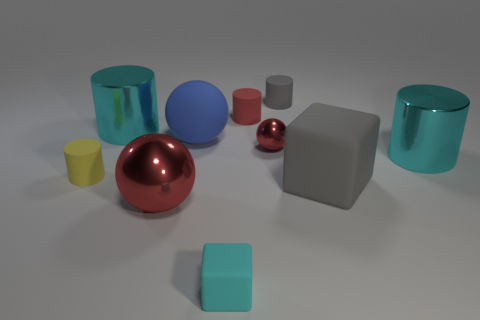How many other rubber objects are the same shape as the big red thing? 1 